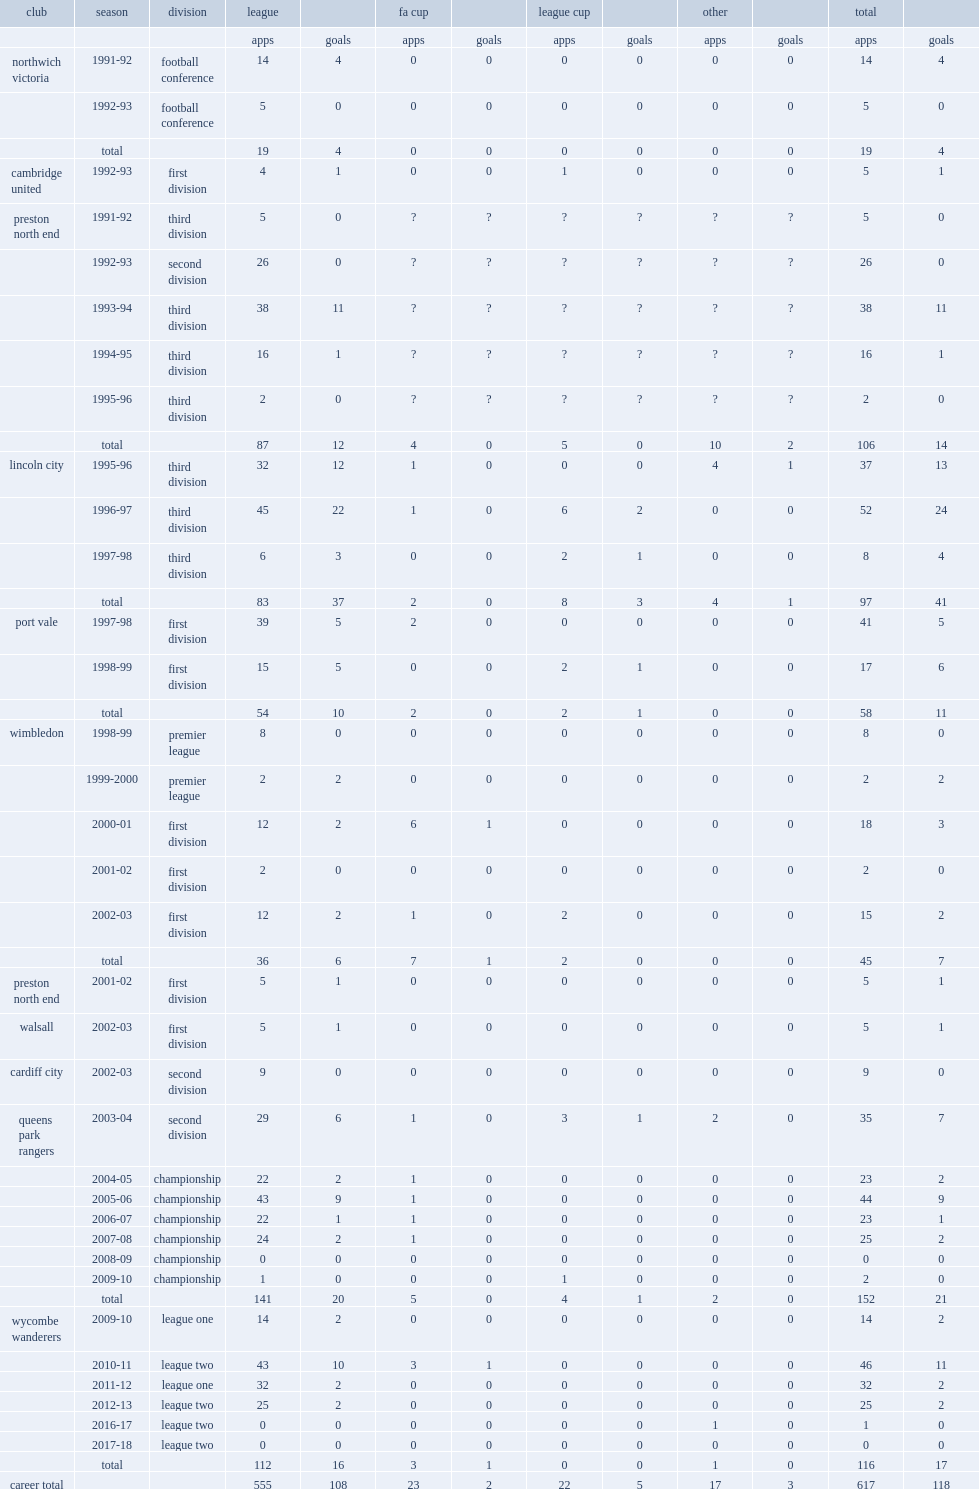Which club did gareth ainsworth play for in 1996-97? Lincoln city. 